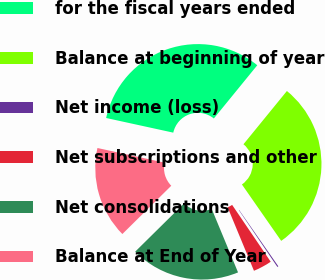<chart> <loc_0><loc_0><loc_500><loc_500><pie_chart><fcel>for the fiscal years ended<fcel>Balance at beginning of year<fcel>Net income (loss)<fcel>Net subscriptions and other<fcel>Net consolidations<fcel>Balance at End of Year<nl><fcel>32.47%<fcel>29.43%<fcel>0.19%<fcel>3.23%<fcel>18.86%<fcel>15.82%<nl></chart> 